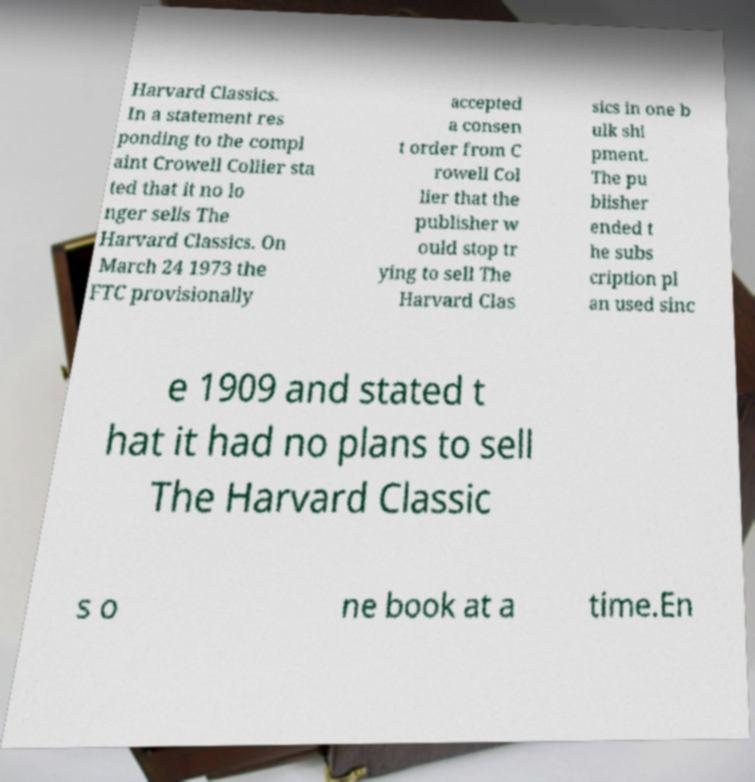For documentation purposes, I need the text within this image transcribed. Could you provide that? Harvard Classics. In a statement res ponding to the compl aint Crowell Collier sta ted that it no lo nger sells The Harvard Classics. On March 24 1973 the FTC provisionally accepted a consen t order from C rowell Col lier that the publisher w ould stop tr ying to sell The Harvard Clas sics in one b ulk shi pment. The pu blisher ended t he subs cription pl an used sinc e 1909 and stated t hat it had no plans to sell The Harvard Classic s o ne book at a time.En 